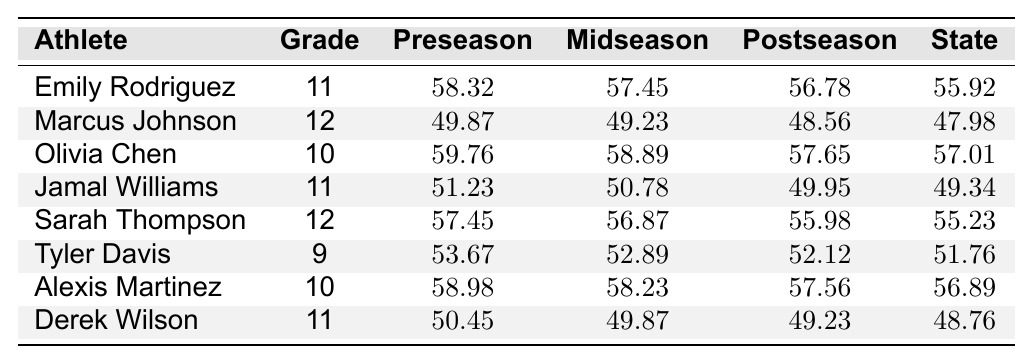What is Emily Rodriguez's personal best time at the state championship? The table lists Emily Rodriguez's performance at the state championship, which shows a time of 55.92 seconds.
Answer: 55.92 seconds Who had the fastest preseason time among the athletes? By comparing the preseason times in the table, Marcus Johnson has the fastest time of 49.87 seconds.
Answer: Marcus Johnson What is the difference between Tyler Davis's postseason and state championship times? Tyler Davis's postseason time is 52.12 seconds, and his state championship time is 51.76 seconds. The difference is calculated as 52.12 - 51.76 = 0.36 seconds.
Answer: 0.36 seconds Did Jamal Williams improve his time from the preseason to the state championship? Jamal Williams's preseason time was 51.23 seconds, and his state championship time was 49.34 seconds, indicating an improvement.
Answer: Yes What is the average state championship time for athletes in 11th grade? The state championship times for 11th graders are 55.92, 49.34, and 48.76 seconds. To find the average, sum those times (55.92 + 49.34 + 48.76 = 153.02) and divide by 3, resulting in 153.02 / 3 = 51.01 seconds.
Answer: 51.01 seconds Which athlete had the highest improvement from preseason to postseason? To find the highest improvement, we calculate the difference between preseason and postseason for each athlete. The highest improvement is for Emily Rodriguez, who improved from 58.32 seconds to 56.78 seconds, showing an improvement of 1.54 seconds.
Answer: Emily Rodriguez What was Marcus Johnson's midseason time? According to the table, Marcus Johnson's midseason time is 49.23 seconds.
Answer: 49.23 seconds Which athlete had the most consistent times across the season? Consistency can be assessed by looking at the differences between the preseason, midseason, postseason, and state championship times. Derek Wilson had times of 50.45, 49.87, 49.23, and 48.76 seconds, showing small variations, indicating consistency.
Answer: Derek Wilson What is the total improvement for Olivia Chen from preseason to state championship? Olivia Chen's preseason time is 59.76 seconds, and her state championship time is 57.01 seconds. The total improvement is calculated as 59.76 - 57.01 = 2.75 seconds.
Answer: 2.75 seconds Is there any athlete who finished with a postseason time faster than their midseason time? Yes, both Tyler Davis and Jamal Williams improved their postseason times compared to their midseason times, indicating they performed better at the end of the season.
Answer: Yes What was the slowest state championship time recorded in this data? By reviewing the state championship times in the table, Tyler Davis has the slowest time of 51.76 seconds.
Answer: 51.76 seconds 